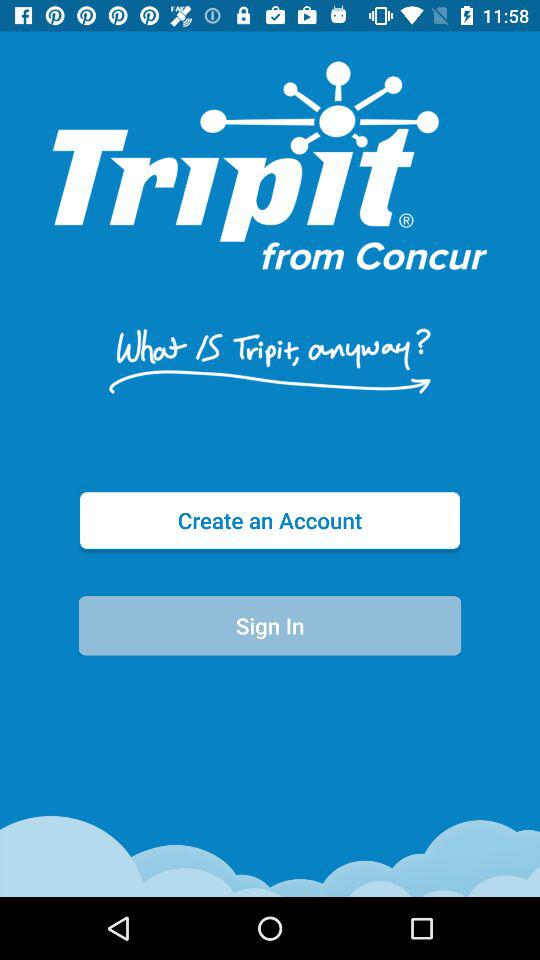What is the application name? The application name is "Tripit". 